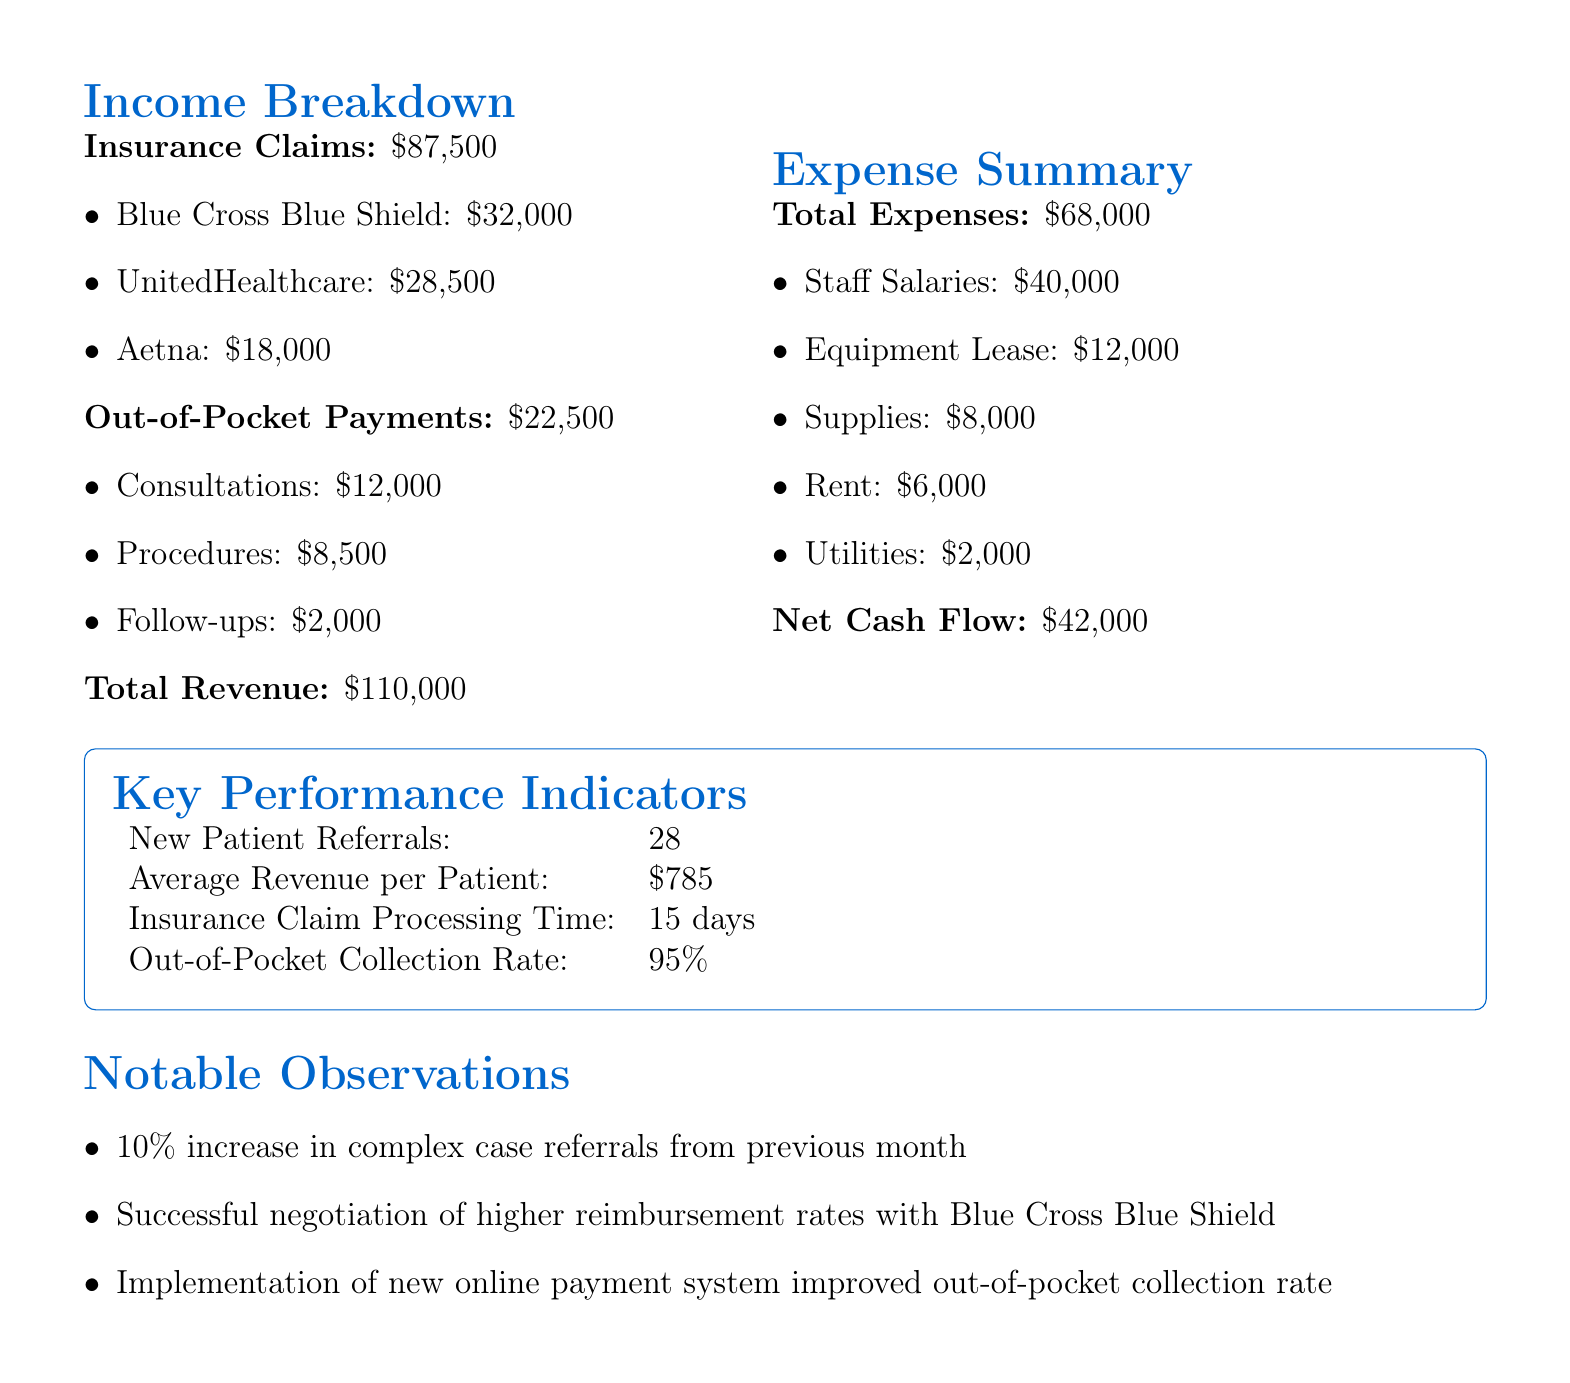what is the total income from insurance claims? The document lists a total of $87,500 generated from insurance claims.
Answer: $87,500 what is the largest source of out-of-pocket payments? The out-of-pocket payment from consultations amounts to $12,000, which is the highest compared to other categories.
Answer: $12,000 what is the net cash flow for May 2023? The document states the net cash flow for the month as $42,000.
Answer: $42,000 how many new patient referrals were made? The report indicates that there were 28 new patient referrals in May 2023.
Answer: 28 what percentage of out-of-pocket payments were collected? The document shows an out-of-pocket collection rate of 95%.
Answer: 95% which insurance provider contributed the least to the total insurance claims? Among the listed providers, Aetna contributed the least with $18,000.
Answer: Aetna what is the total amount spent on staff salaries? The document specifies that the total amount spent on staff salaries is $40,000.
Answer: $40,000 what notable observation relates to the reimbursement rates? The document notes a successful negotiation of higher reimbursement rates with Blue Cross Blue Shield.
Answer: Higher reimbursement rates with Blue Cross Blue Shield how much were the total expenses for the clinic? According to the report, the total expenses amounted to $68,000.
Answer: $68,000 what was the revenue from procedures in out-of-pocket payments? The report lists that the revenue from procedures in out-of-pocket payments was $8,500.
Answer: $8,500 